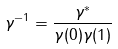<formula> <loc_0><loc_0><loc_500><loc_500>\gamma ^ { - 1 } = \frac { \gamma ^ { * } } { \gamma ( 0 ) \gamma ( 1 ) }</formula> 